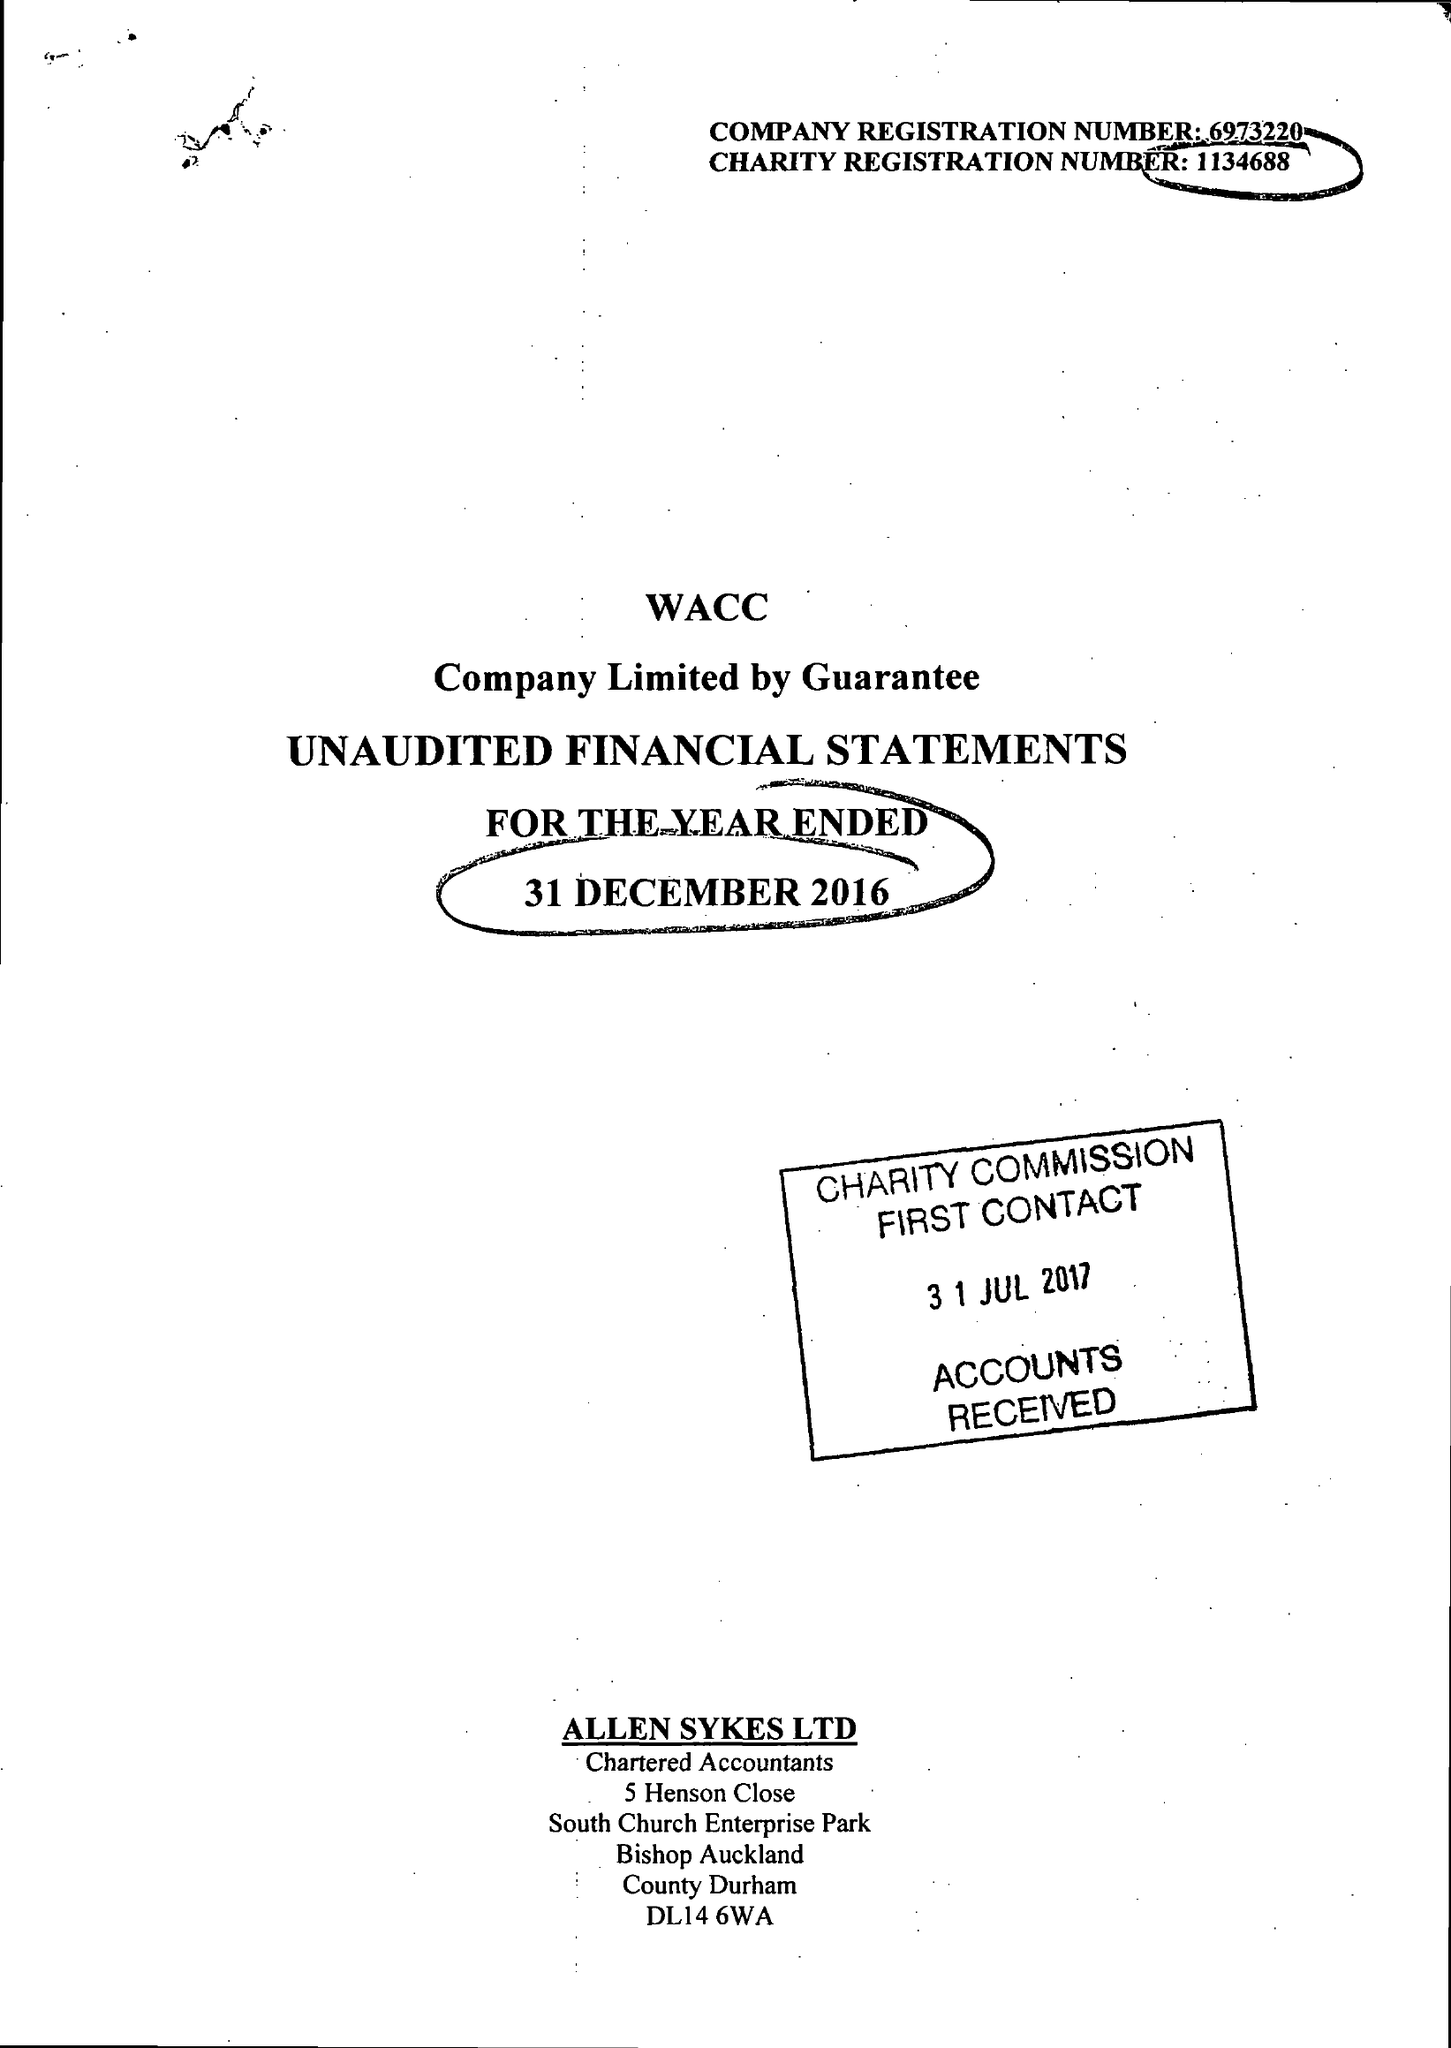What is the value for the report_date?
Answer the question using a single word or phrase. 2016-12-31 